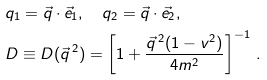Convert formula to latex. <formula><loc_0><loc_0><loc_500><loc_500>& q _ { 1 } = { \vec { q } } \cdot { \vec { e } } _ { 1 } , \quad q _ { 2 } = { \vec { q } } \cdot { \vec { e } } _ { 2 } , \\ & D \equiv D ( \vec { q } ^ { \, 2 } ) = \left [ 1 + \frac { { \vec { q } } ^ { \, 2 } ( 1 - v ^ { 2 } ) } { 4 m ^ { 2 } } \right ] ^ { - 1 } \, .</formula> 